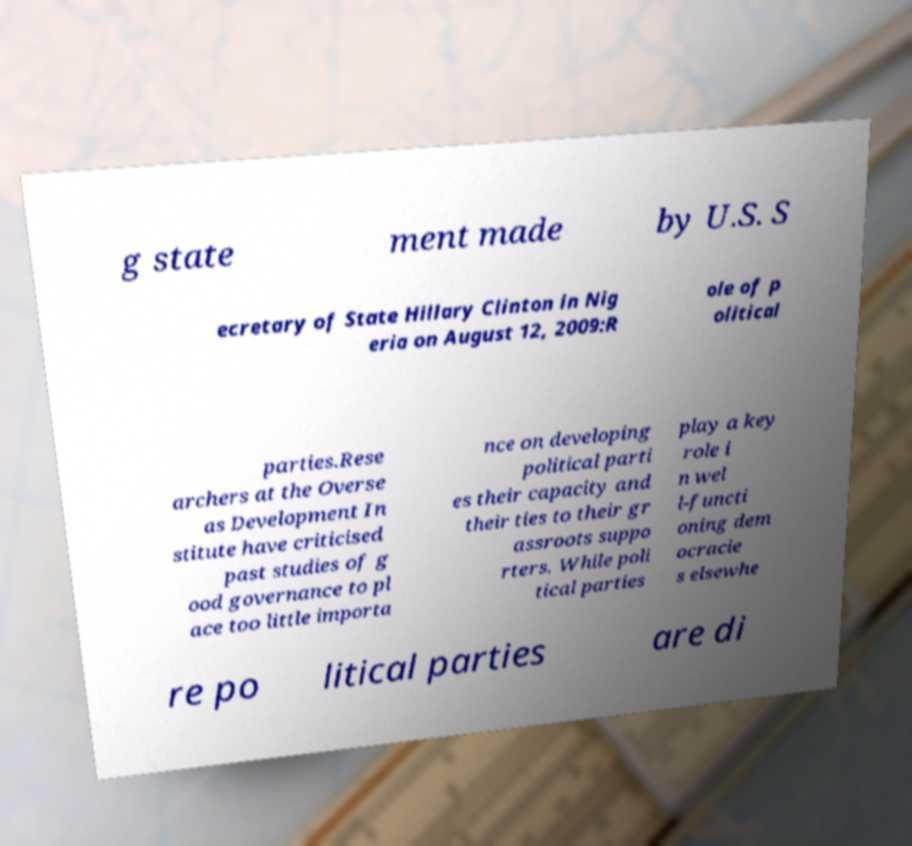Could you extract and type out the text from this image? g state ment made by U.S. S ecretary of State Hillary Clinton in Nig eria on August 12, 2009:R ole of p olitical parties.Rese archers at the Overse as Development In stitute have criticised past studies of g ood governance to pl ace too little importa nce on developing political parti es their capacity and their ties to their gr assroots suppo rters. While poli tical parties play a key role i n wel l-functi oning dem ocracie s elsewhe re po litical parties are di 